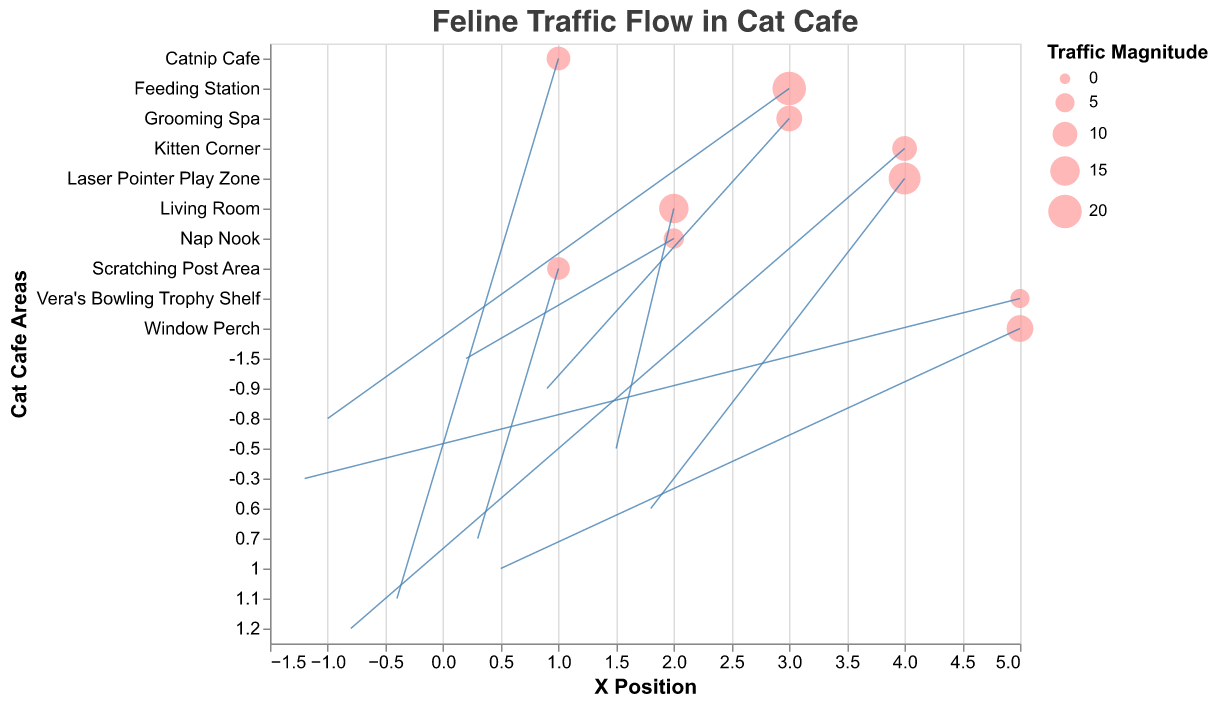How many areas in the cat cafe have traffic data represented in the plot? To count the number of areas, we look at the distinct areas listed in the y-axis labels. Each represents an area in the cat cafe.
Answer: 10 Which area has the highest traffic magnitude? The size of the points represents the traffic magnitude. The largest circle indicates the highest magnitude. By identifying the largest point, we find the area with the highest traffic. The area with the largest circle is the Feeding Station with a magnitude of 20.
Answer: Feeding Station How does the traffic magnitude of the Laser Pointer Play Zone compare to that of the Grooming Spa? We look at the sizes of the points representing these two areas. The Laser Pointer Play Zone has a value of 18, while the Grooming Spa has a value of 11.
Answer: Laser Pointer Play Zone has a higher traffic magnitude than the Grooming Spa What is the direction of feline movement in the Window Perch? In a quiver plot, the direction is indicated by the arrows. For the Window Perch, the vector components (u=0.5, v=1.0) show an upward-right movement.
Answer: Upward-right In which area do cats tend to move leftwards more than rightwards? We look for negative values in the u component of the vectors, which indicate leftward movement. Areas with such vectors include Kitten Corner, Feeding Station, Catnip Cafe, and Vera's Bowling Trophy Shelf. Any of these can be a correct answer depending on which direction is more pronounced. Feeding Station and Vera's Bowling Trophy Shelf have larger negative u values than the other.
Answer: Feeding Station What areas do the vectors with the largest magnitude point to? We calculate magnitudes by looking at the lengths of vectors. The vectors with the highest magnitudes will usually be those representing the longest arrows. The Feeding Station has the largest magnitude of 20.
Answer: Feeding Station Which area shows feline movement mostly downward? Look for vectors with a significant negative v component. Nap Nook (v = -1.5) is the most downward as indicated by the largest negative v value.
Answer: Nap Nook What is the average traffic magnitude of the areas with bi-directional movement (both u and v components are not zero)? First, identify areas where both u and v components are not zero: Living Room, Kitten Corner, Scratching Post Area, Feeding Station, Window Perch, Laser Pointer Play Zone, Catnip Cafe, Grooming Spa. Sum their magnitudes: 15+10+8+20+12+18+9+11 = 103. Divide by 8 to find the average.
Answer: 12.875 Which area has the smallest traffic magnitude and what is its direction? To find the smallest traffic magnitude, look for the smallest circle. Vera's Bowling Trophy Shelf has the smallest magnitude (5). The direction (u = -1.2, v = -0.3) indicates a downward-left movement.
Answer: Vera's Bowling Trophy Shelf, downward-left What is the average traffic magnitude for the areas where cats move predominantly upward? Select areas where the v component is positive: Kitten Corner, Scratching Post Area, Window Perch, Laser Pointer Play Zone, and Catnip Cafe. Sum their magnitudes: 10+8+12+18+9 = 57. Divide by 5 to find the average.
Answer: 11.4 